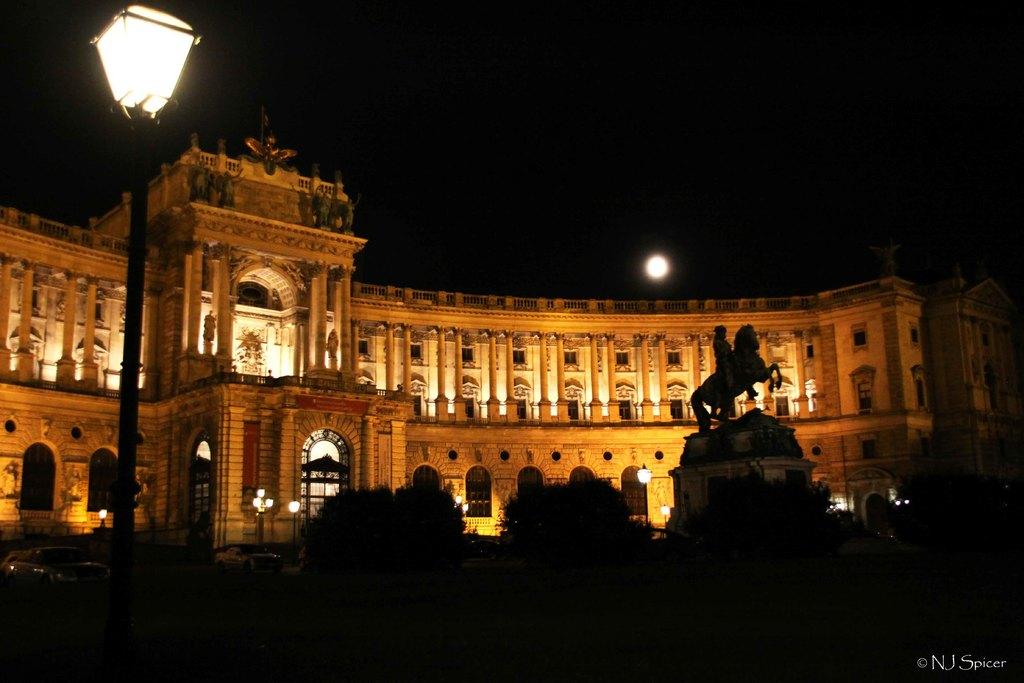What type of structure can be seen in the image? There is a building in the image. What are the light poles used for in the image? The light poles provide illumination in the image. What type of art is present in the image? There are statues in the image. What type of vegetation is present in the image? There are plants in the image. What type of transportation is present in the image? There are vehicles in the image. What celestial body is visible in the image? The moon is visible in the image. What is the color of the sky in the image? The sky is dark in the image. What is present in the image that is not a part of the scene? There is a watermark at the bottom right side of the image. How many goldfish are swimming in the watermark at the bottom right side of the image? There are no goldfish present in the image, as the watermark is not a part of the scene. What type of teeth can be seen on the statues in the image? There are no teeth visible on the statues in the image, as statues typically do not have teeth. 